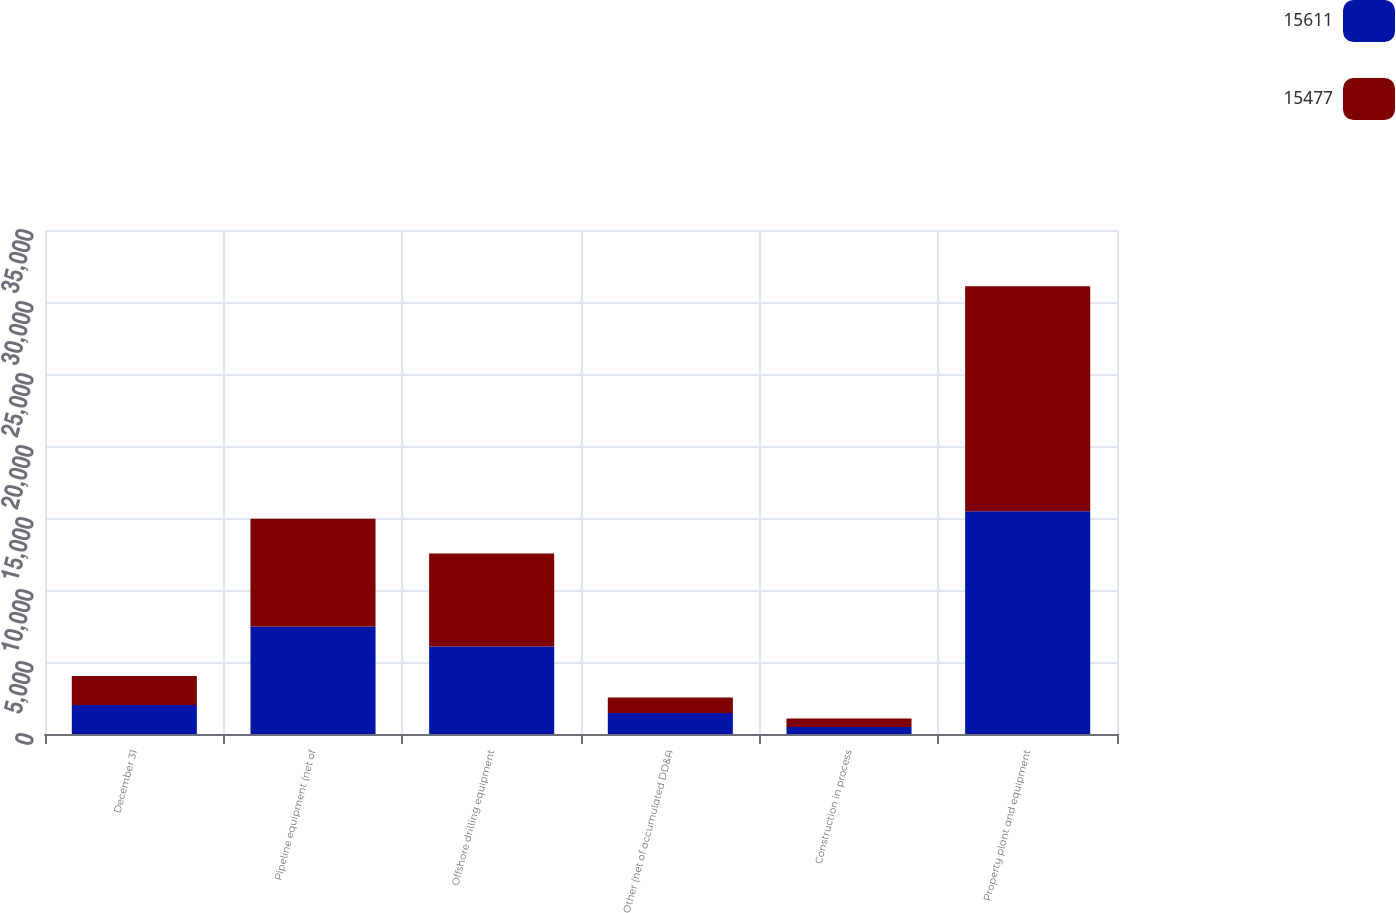Convert chart to OTSL. <chart><loc_0><loc_0><loc_500><loc_500><stacked_bar_chart><ecel><fcel>December 31<fcel>Pipeline equipment (net of<fcel>Offshore drilling equipment<fcel>Other (net of accumulated DD&A<fcel>Construction in process<fcel>Property plant and equipment<nl><fcel>15611<fcel>2015<fcel>7462<fcel>6071<fcel>1450<fcel>494<fcel>15477<nl><fcel>15477<fcel>2014<fcel>7491<fcel>6459<fcel>1083<fcel>578<fcel>15611<nl></chart> 